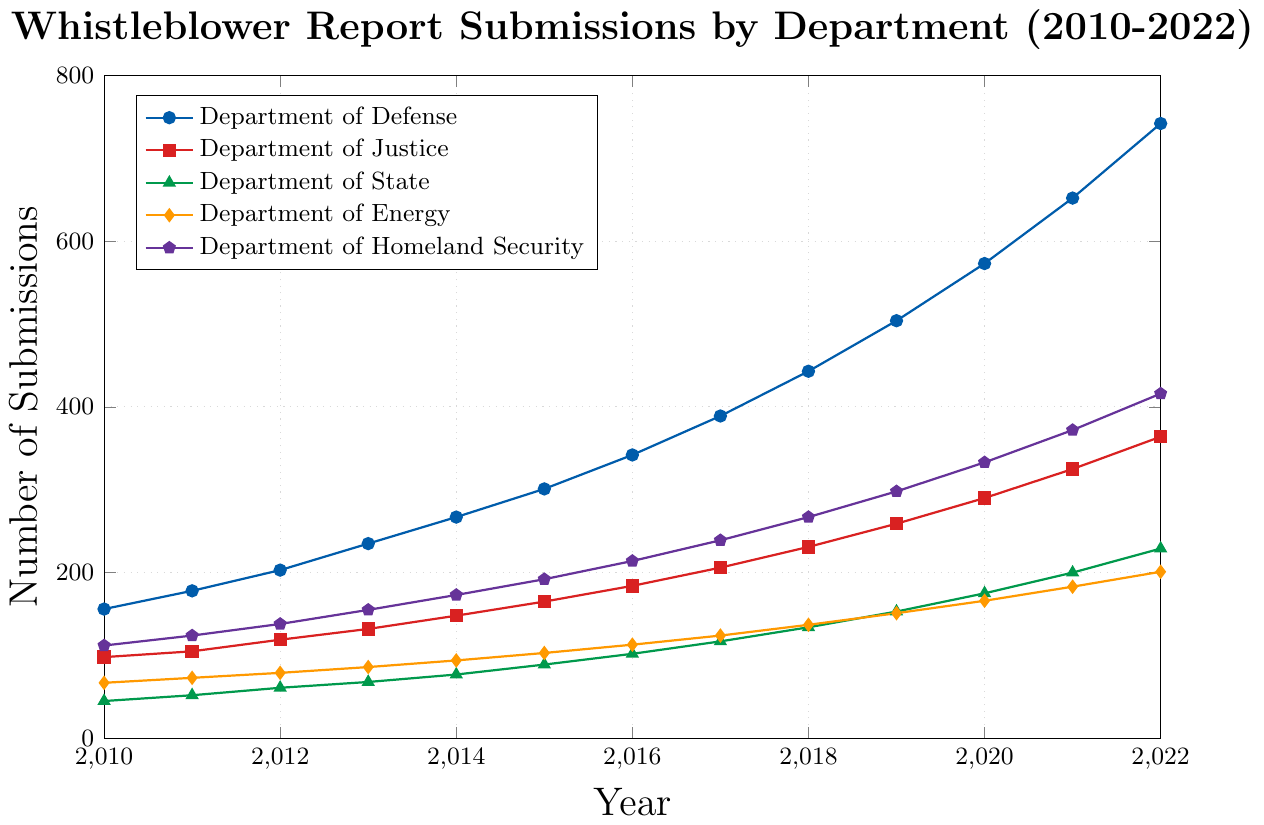What was the total number of whistleblower report submissions for the Department of Energy and Department of Homeland Security in 2015? From the figure, the number of submissions for the Department of Energy in 2015 is 103, and for the Department of Homeland Security, it is 192. Add these two numbers together: 103 + 192 = 295
Answer: 295 In which year did the Department of Defense surpass 500 whistleblower report submissions? The data points for the Department of Defense are plotted and can be visually analyzed. The submissions surpass 500 in 2019 with 504 submissions.
Answer: 2019 Between 2010 and 2022, which department had the smallest overall increase in whistleblower report submissions? Comparing the starting and ending points for each department, the Department of State starts at 45 submissions in 2010 and ends with 229 in 2022. The difference for the Department of State is 229 - 45 = 184. Other departments have larger differences.
Answer: Department of State What is the average number of submissions for the Department of Justice from 2010 to 2015? The data points for the Department of Justice from 2010 to 2015 are (98, 105, 119, 132, 148, 165). Sum these values: 98 + 105 + 119 + 132 + 148 + 165 = 767. Now divide by the number of years: 767 / 6 = 127.83
Answer: 127.83 What is the difference in the number of submissions between the Department of Defense and the Department of Justice in 2022? In 2022, the Department of Defense had 742 submissions, and the Department of Justice had 364. The difference is 742 - 364 = 378
Answer: 378 Which department showed a consistent increase every year without any decline? By examining the chart, we can see that each department’s line either remains steady or increases each year without any dips. Therefore, all five departments: Department of Defense, Department of Justice, Department of State, Department of Energy, and Department of Homeland Security showed consistent increases.
Answer: All departments How many more submissions did the Department of Homeland Security have in 2022 compared to 2010? The Department of Homeland Security had 112 submissions in 2010 and 416 submissions in 2022. The difference is 416 - 112 = 304
Answer: 304 Which department had the lowest submissions in 2016 and how many? From the plotted lines, the Department of State had the lowest number of submissions in 2016 with 102 submissions.
Answer: Department of State, 102 What is the compound annual growth rate (CAGR) for the Department of Defense submissions from 2010 to 2022? The formula for CAGR is {\((\frac{value_{end}}{value_{start}})^{\frac{1}{n}} - 1\)}. Here, \(\frac{742}{156} = 4.7564\). Taking the 12th root (since \(n=12\)), we get 4.7564^{\frac{1}{12}} \approx 1.1353. Subtracting 1 gives us 0.1353 or 13.53%.
Answer: 13.53% What's the total number of submissions across all departments in the year 2020? Sum the submissions in 2020 for all departments: 573 (DoD) + 290 (DoJ) + 175 (DoS) + 166 (DoE) + 333 (DHS) = 1537
Answer: 1537 